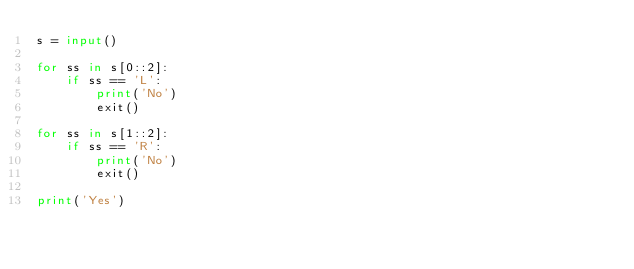Convert code to text. <code><loc_0><loc_0><loc_500><loc_500><_Python_>s = input()

for ss in s[0::2]:
    if ss == 'L':
        print('No')
        exit()

for ss in s[1::2]:
    if ss == 'R':
        print('No')
        exit()

print('Yes')
</code> 